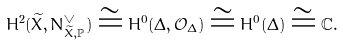Convert formula to latex. <formula><loc_0><loc_0><loc_500><loc_500>H ^ { 2 } ( \widetilde { X } , N _ { \widetilde { X } , \mathbb { P } } ^ { \vee } ) \cong H ^ { 0 } ( \Delta , \mathcal { O } _ { \Delta } ) \cong H ^ { 0 } ( \Delta ) \cong \mathbb { C } .</formula> 